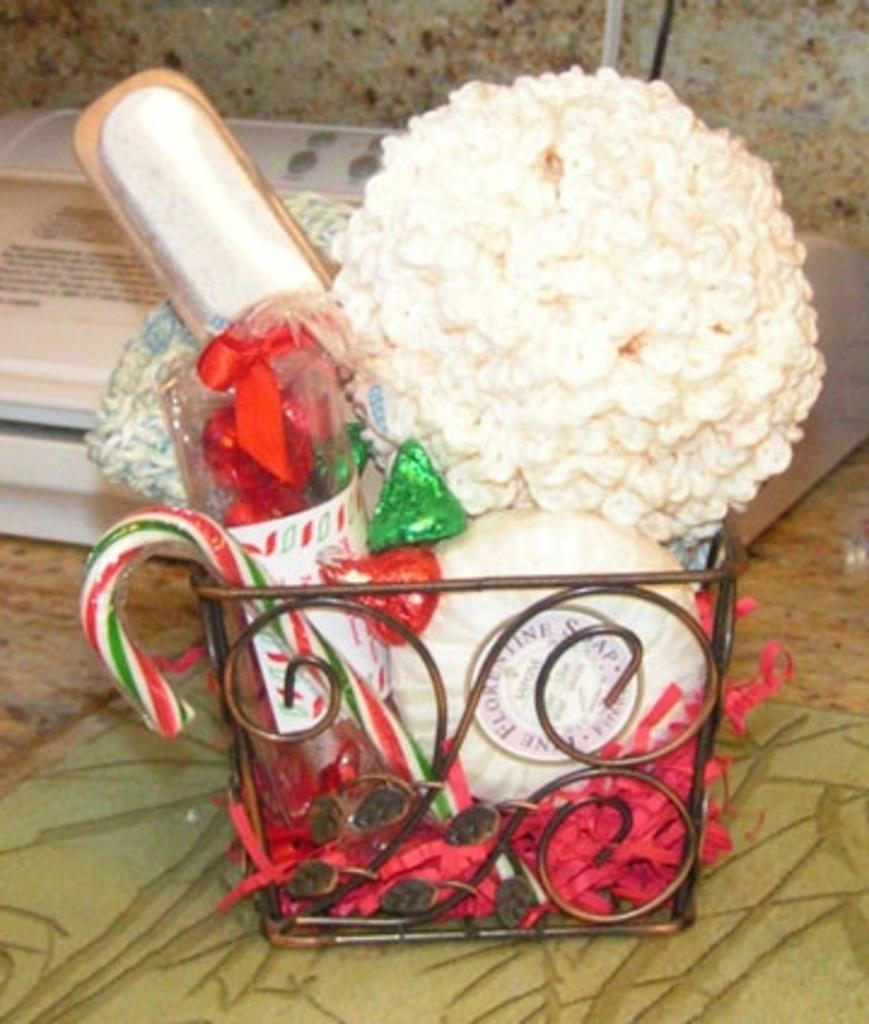What is present in the image that can hold items? There is a basket in the image that can hold items. What can be seen on top of the basket? There are objects placed on the basket. What is located behind the basket in the image? There is a box visible behind the basket. What type of plants can be seen growing in the aftermath of the image? There are no plants or any indication of an aftermath in the image; it only features a basket with objects on it and a box behind it. 